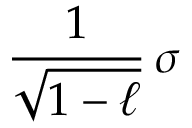<formula> <loc_0><loc_0><loc_500><loc_500>{ \frac { 1 } { \sqrt { 1 - \ell } } } \, \sigma</formula> 